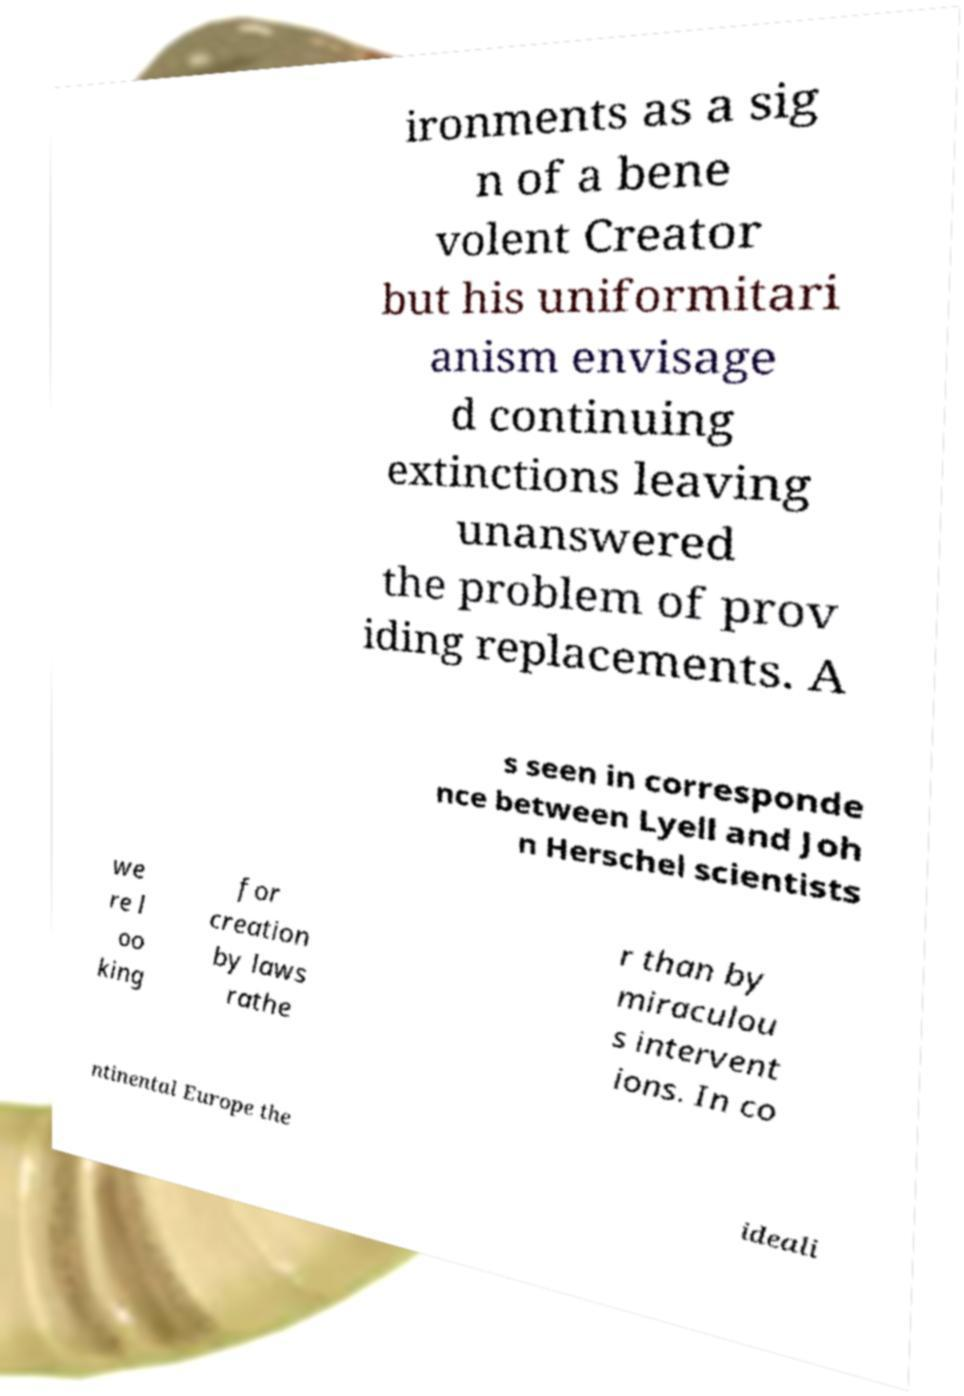For documentation purposes, I need the text within this image transcribed. Could you provide that? ironments as a sig n of a bene volent Creator but his uniformitari anism envisage d continuing extinctions leaving unanswered the problem of prov iding replacements. A s seen in corresponde nce between Lyell and Joh n Herschel scientists we re l oo king for creation by laws rathe r than by miraculou s intervent ions. In co ntinental Europe the ideali 